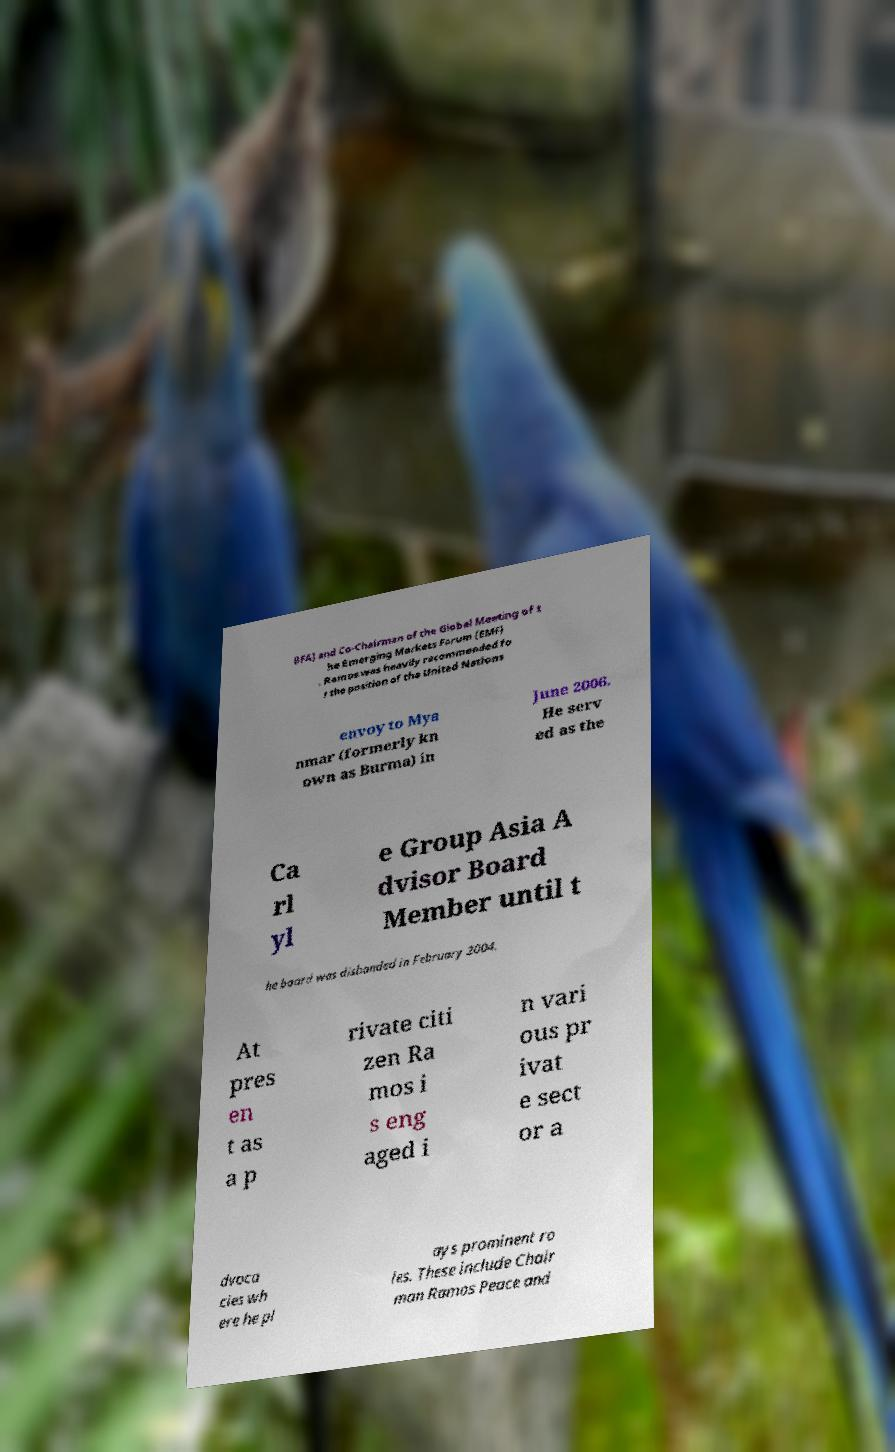I need the written content from this picture converted into text. Can you do that? BFA) and Co-Chairman of the Global Meeting of t he Emerging Markets Forum (EMF) . Ramos was heavily recommended fo r the position of the United Nations envoy to Mya nmar (formerly kn own as Burma) in June 2006. He serv ed as the Ca rl yl e Group Asia A dvisor Board Member until t he board was disbanded in February 2004. At pres en t as a p rivate citi zen Ra mos i s eng aged i n vari ous pr ivat e sect or a dvoca cies wh ere he pl ays prominent ro les. These include Chair man Ramos Peace and 